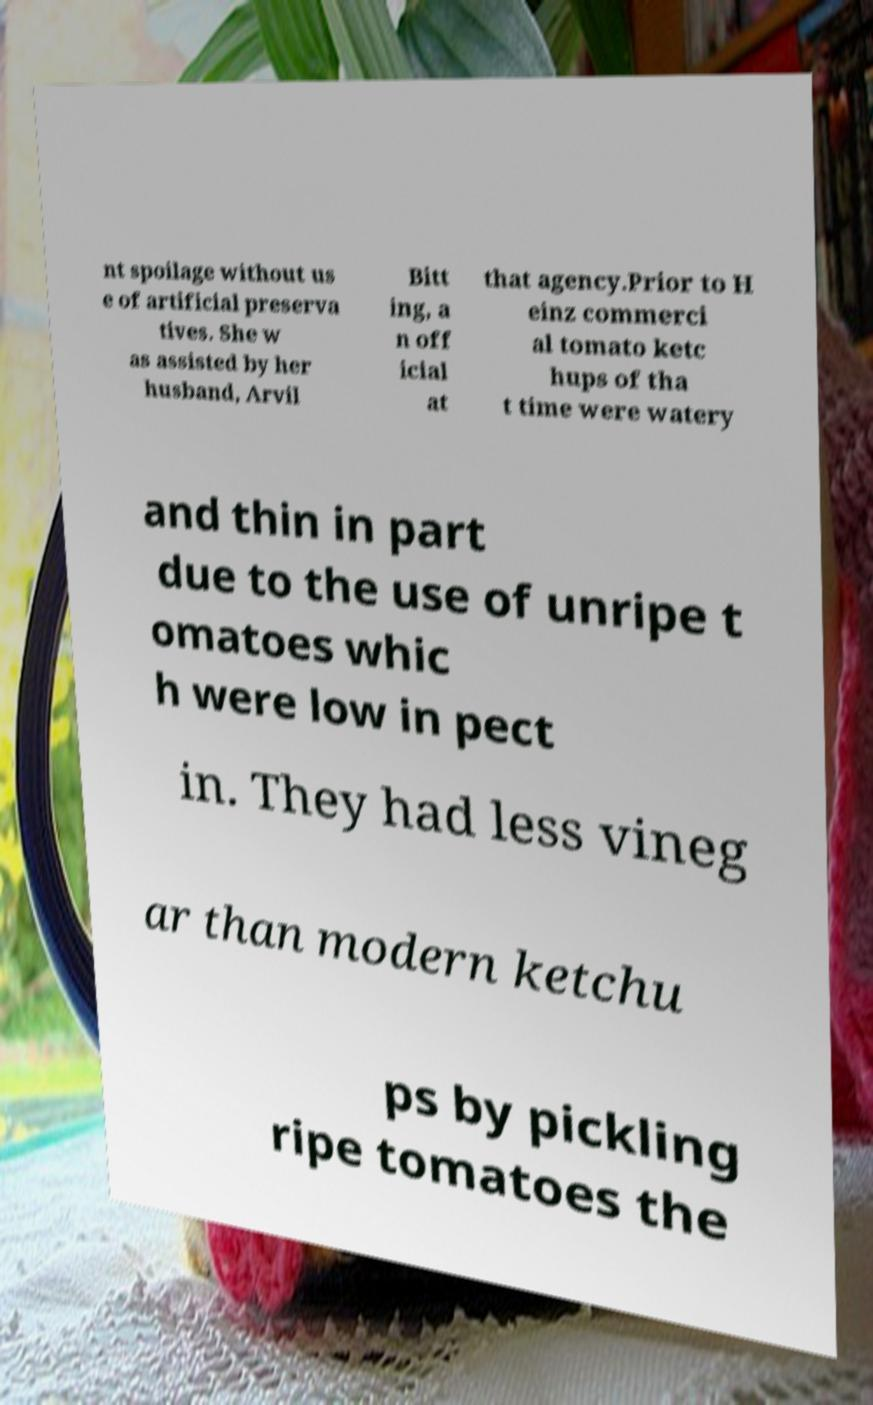There's text embedded in this image that I need extracted. Can you transcribe it verbatim? nt spoilage without us e of artificial preserva tives. She w as assisted by her husband, Arvil Bitt ing, a n off icial at that agency.Prior to H einz commerci al tomato ketc hups of tha t time were watery and thin in part due to the use of unripe t omatoes whic h were low in pect in. They had less vineg ar than modern ketchu ps by pickling ripe tomatoes the 